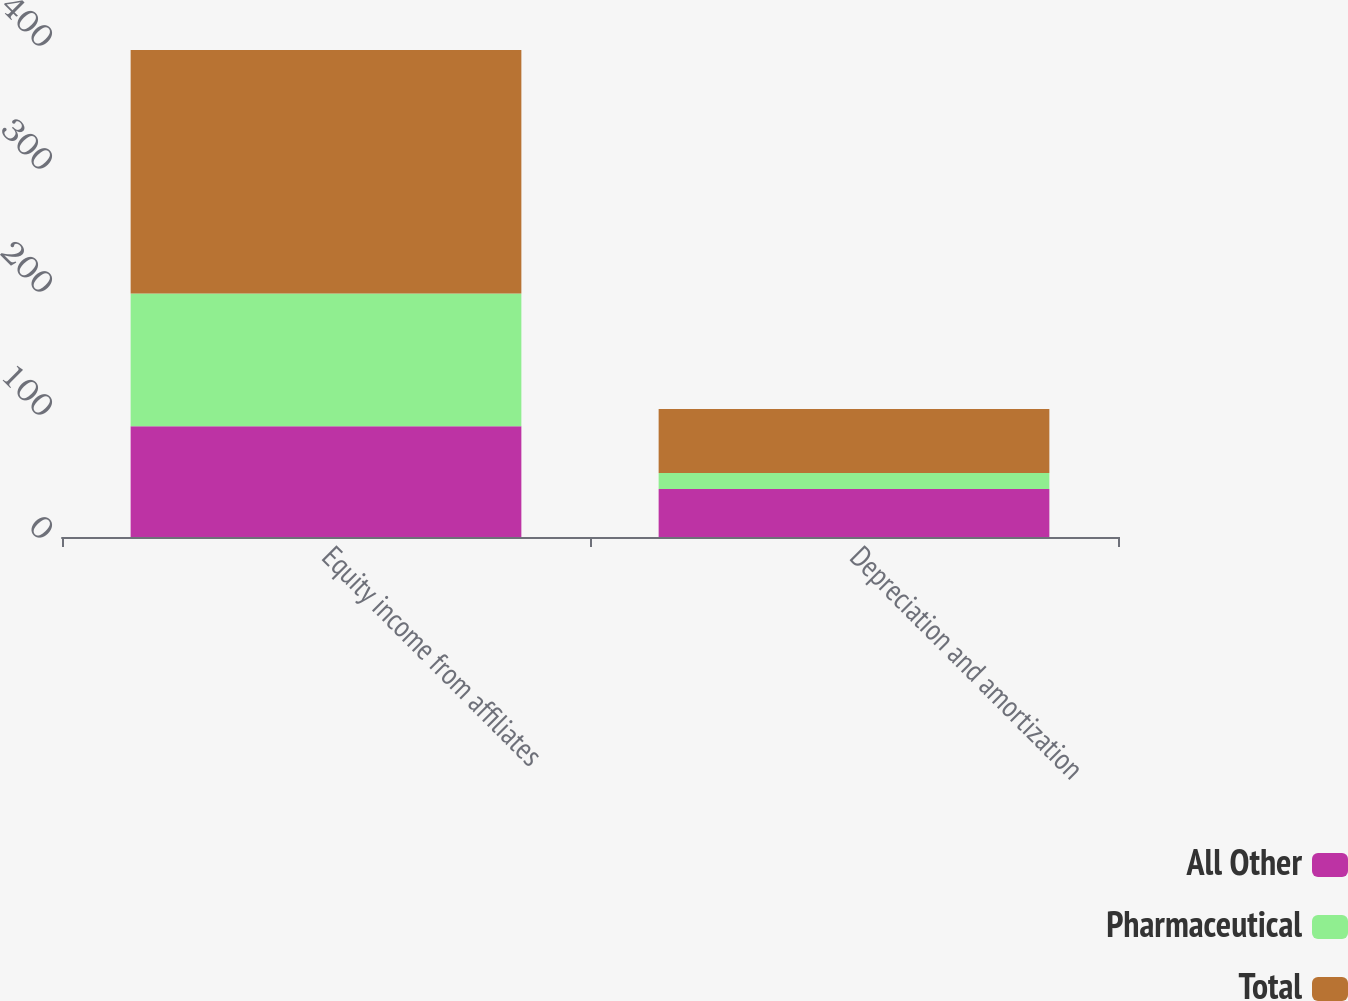Convert chart. <chart><loc_0><loc_0><loc_500><loc_500><stacked_bar_chart><ecel><fcel>Equity income from affiliates<fcel>Depreciation and amortization<nl><fcel>All Other<fcel>90<fcel>39<nl><fcel>Pharmaceutical<fcel>108<fcel>13<nl><fcel>Total<fcel>198<fcel>52<nl></chart> 